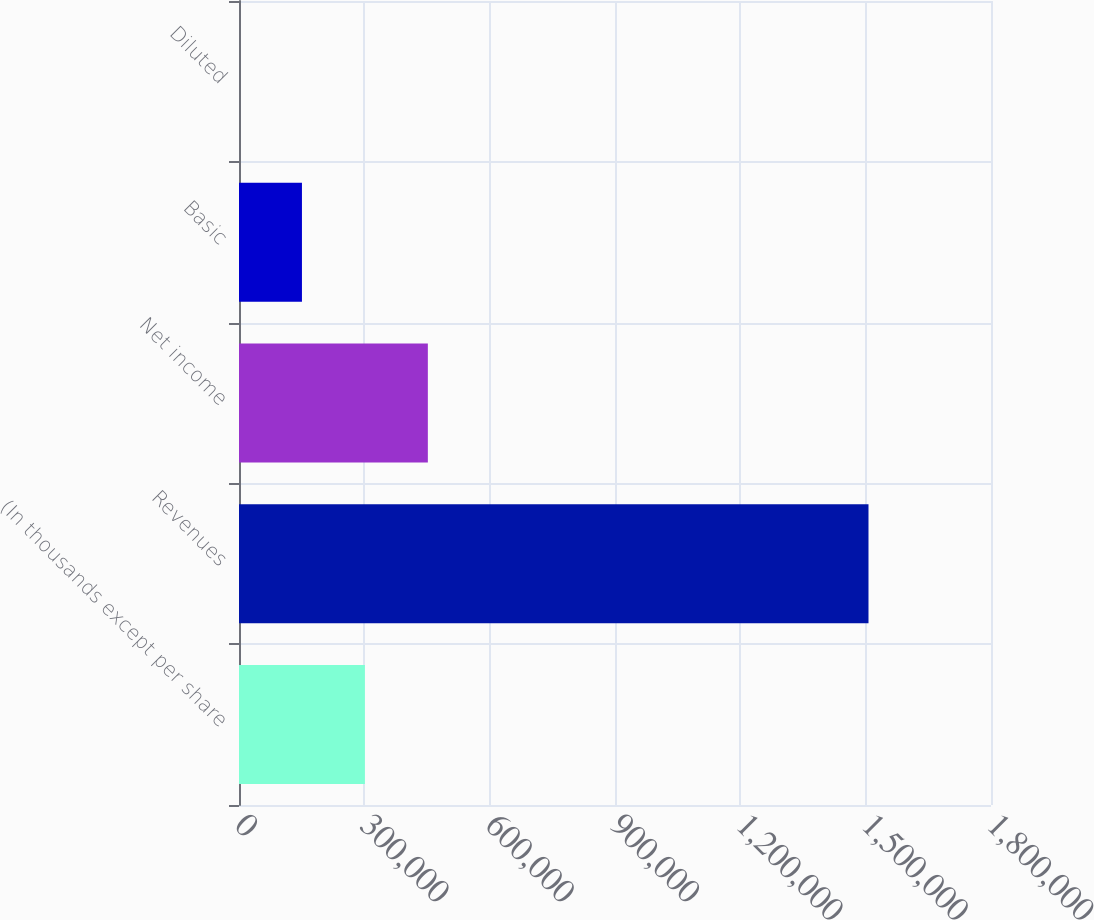Convert chart to OTSL. <chart><loc_0><loc_0><loc_500><loc_500><bar_chart><fcel>(In thousands except per share<fcel>Revenues<fcel>Net income<fcel>Basic<fcel>Diluted<nl><fcel>301354<fcel>1.50677e+06<fcel>452031<fcel>150678<fcel>0.83<nl></chart> 